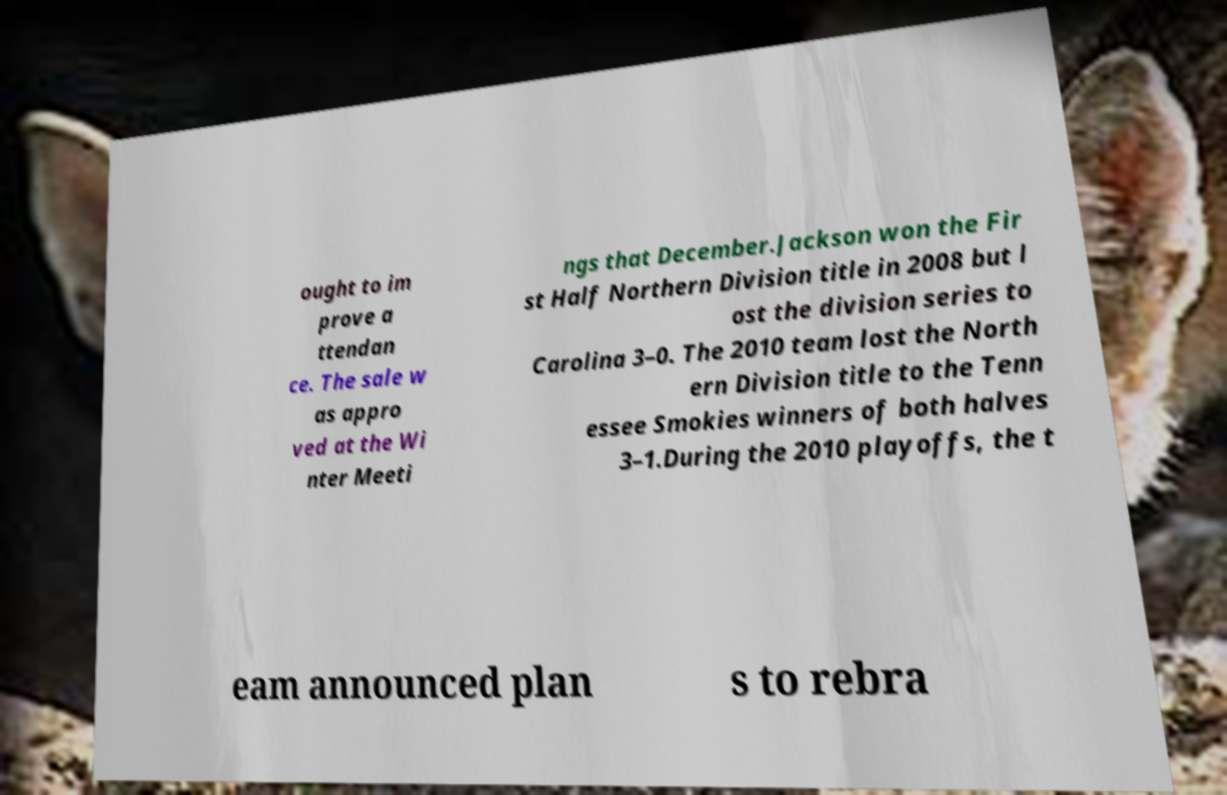Please identify and transcribe the text found in this image. ought to im prove a ttendan ce. The sale w as appro ved at the Wi nter Meeti ngs that December.Jackson won the Fir st Half Northern Division title in 2008 but l ost the division series to Carolina 3–0. The 2010 team lost the North ern Division title to the Tenn essee Smokies winners of both halves 3–1.During the 2010 playoffs, the t eam announced plan s to rebra 